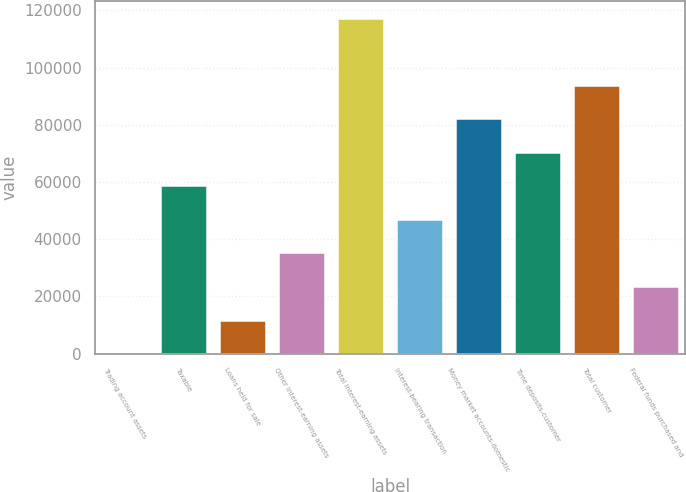Convert chart. <chart><loc_0><loc_0><loc_500><loc_500><bar_chart><fcel>Trading account assets<fcel>Taxable<fcel>Loans held for sale<fcel>Other interest-earning assets<fcel>Total interest-earning assets<fcel>Interest-bearing transaction<fcel>Money market accounts-domestic<fcel>Time deposits-customer<fcel>Total customer<fcel>Federal funds purchased and<nl><fcel>175<fcel>58841<fcel>11908.2<fcel>35374.6<fcel>117507<fcel>47107.8<fcel>82307.4<fcel>70574.2<fcel>94040.6<fcel>23641.4<nl></chart> 